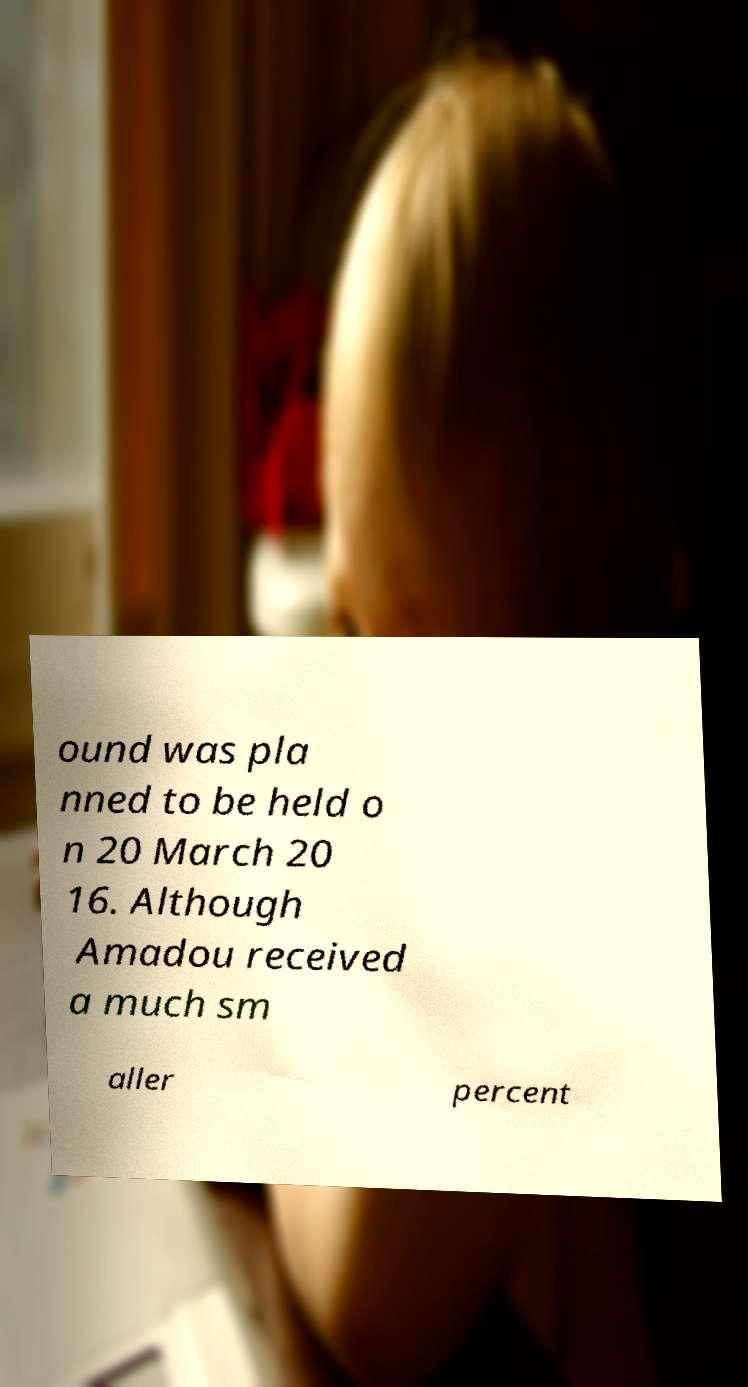Please read and relay the text visible in this image. What does it say? ound was pla nned to be held o n 20 March 20 16. Although Amadou received a much sm aller percent 